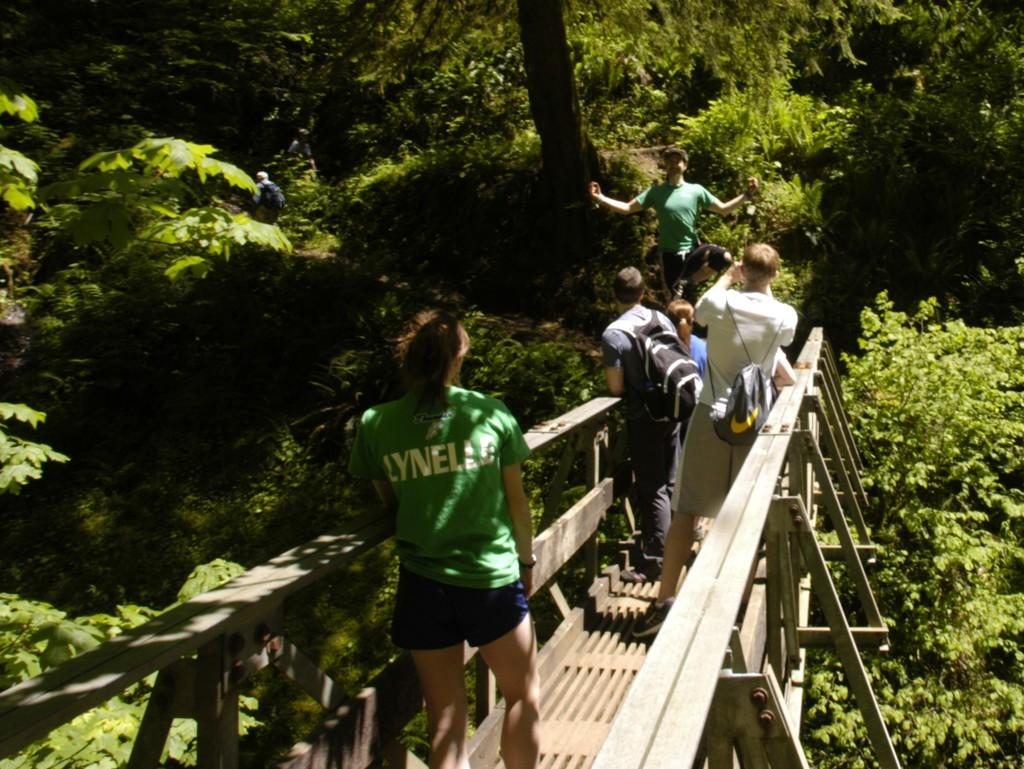What structure is present in the image? There is a bridge in the image. Who or what can be seen in the image besides the bridge? There are people in the image. What are some people in the image wearing? Some people are wearing bags. What type of vegetation is visible in the image? There are trees in the image. Can you tell me how many pigs are walking on the bridge in the image? There are no pigs present in the image; it features a bridge, people, bags, and trees. What type of prose is being recited by the people on the bridge in the image? There is no indication in the image that people are reciting prose or any form of literature. 